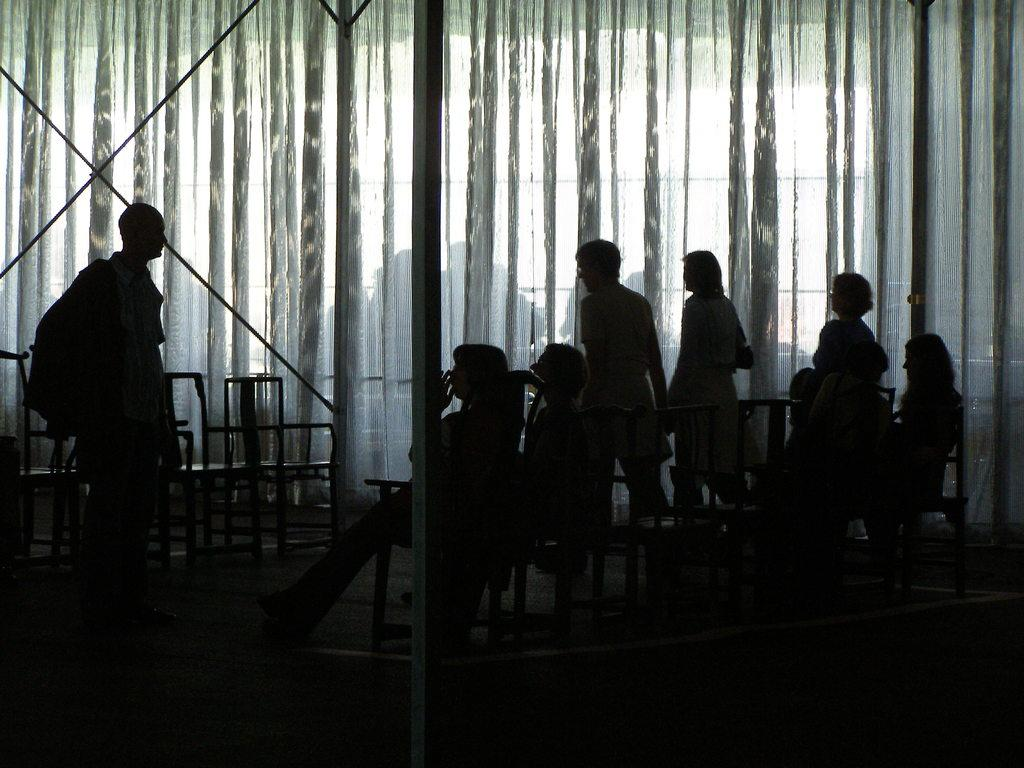How many people are in the image? There are people in the image, but the exact number is not specified. What are some of the people doing in the image? Some people are standing, and some are sitting on chairs. What can be seen in the background of the image? In the background, there are poles, chairs, and other objects. How would you describe the lighting in the image? The image is slightly dark. Can you see a dog playing with sticks in the image? There is no dog or sticks present in the image. What is the purpose of the protest in the image? There is no protest depicted in the image. 